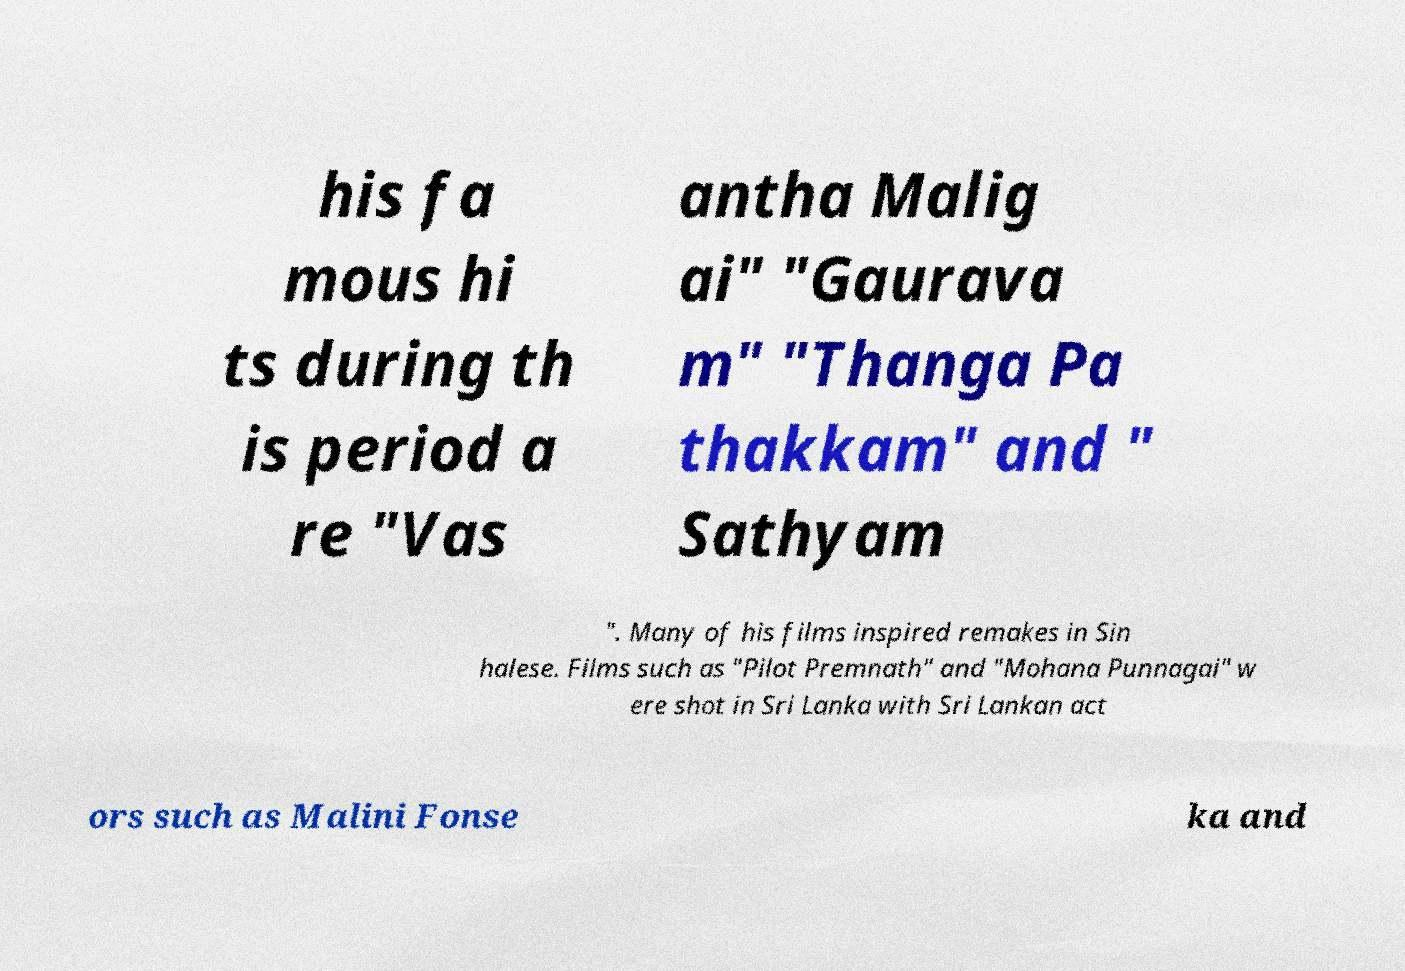Can you accurately transcribe the text from the provided image for me? his fa mous hi ts during th is period a re "Vas antha Malig ai" "Gaurava m" "Thanga Pa thakkam" and " Sathyam ". Many of his films inspired remakes in Sin halese. Films such as "Pilot Premnath" and "Mohana Punnagai" w ere shot in Sri Lanka with Sri Lankan act ors such as Malini Fonse ka and 